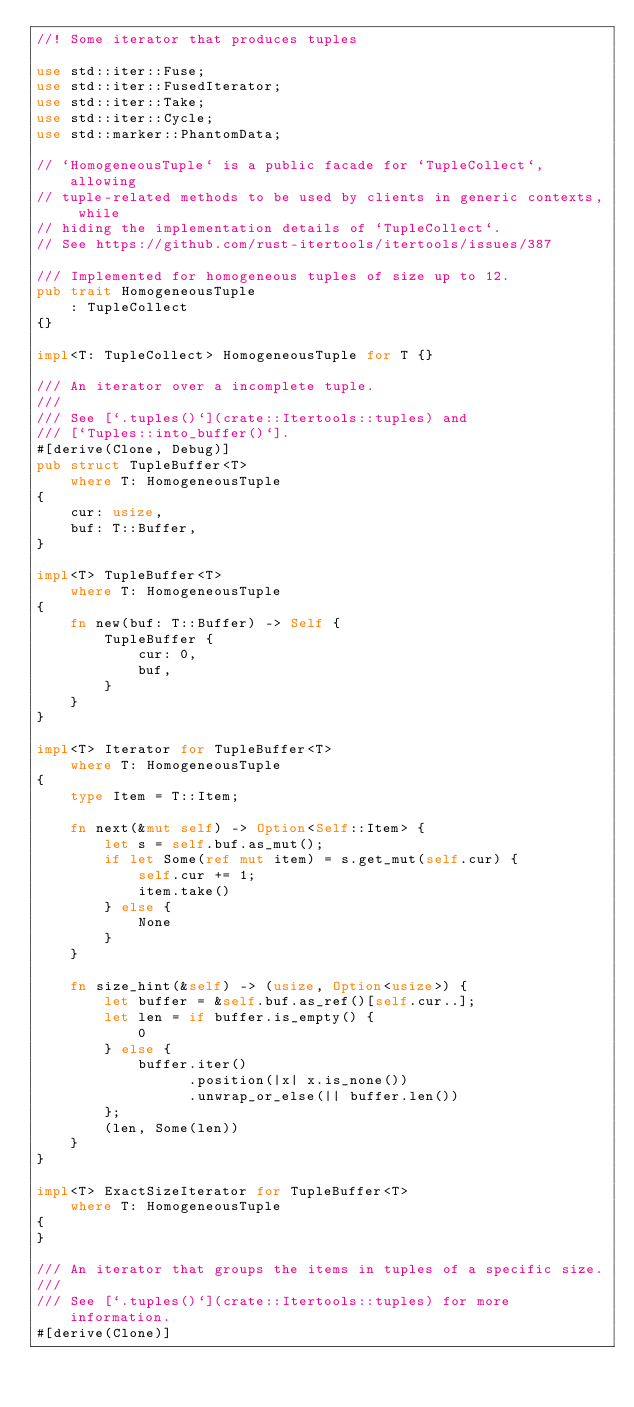Convert code to text. <code><loc_0><loc_0><loc_500><loc_500><_Rust_>//! Some iterator that produces tuples

use std::iter::Fuse;
use std::iter::FusedIterator;
use std::iter::Take;
use std::iter::Cycle;
use std::marker::PhantomData;

// `HomogeneousTuple` is a public facade for `TupleCollect`, allowing
// tuple-related methods to be used by clients in generic contexts, while
// hiding the implementation details of `TupleCollect`.
// See https://github.com/rust-itertools/itertools/issues/387

/// Implemented for homogeneous tuples of size up to 12.
pub trait HomogeneousTuple
    : TupleCollect
{}

impl<T: TupleCollect> HomogeneousTuple for T {}

/// An iterator over a incomplete tuple.
///
/// See [`.tuples()`](crate::Itertools::tuples) and
/// [`Tuples::into_buffer()`].
#[derive(Clone, Debug)]
pub struct TupleBuffer<T>
    where T: HomogeneousTuple
{
    cur: usize,
    buf: T::Buffer,
}

impl<T> TupleBuffer<T>
    where T: HomogeneousTuple
{
    fn new(buf: T::Buffer) -> Self {
        TupleBuffer {
            cur: 0,
            buf,
        }
    }
}

impl<T> Iterator for TupleBuffer<T>
    where T: HomogeneousTuple
{
    type Item = T::Item;

    fn next(&mut self) -> Option<Self::Item> {
        let s = self.buf.as_mut();
        if let Some(ref mut item) = s.get_mut(self.cur) {
            self.cur += 1;
            item.take()
        } else {
            None
        }
    }

    fn size_hint(&self) -> (usize, Option<usize>) {
        let buffer = &self.buf.as_ref()[self.cur..];
        let len = if buffer.is_empty() {
            0
        } else {
            buffer.iter()
                  .position(|x| x.is_none())
                  .unwrap_or_else(|| buffer.len())
        };
        (len, Some(len))
    }
}

impl<T> ExactSizeIterator for TupleBuffer<T>
    where T: HomogeneousTuple
{
}

/// An iterator that groups the items in tuples of a specific size.
///
/// See [`.tuples()`](crate::Itertools::tuples) for more information.
#[derive(Clone)]</code> 